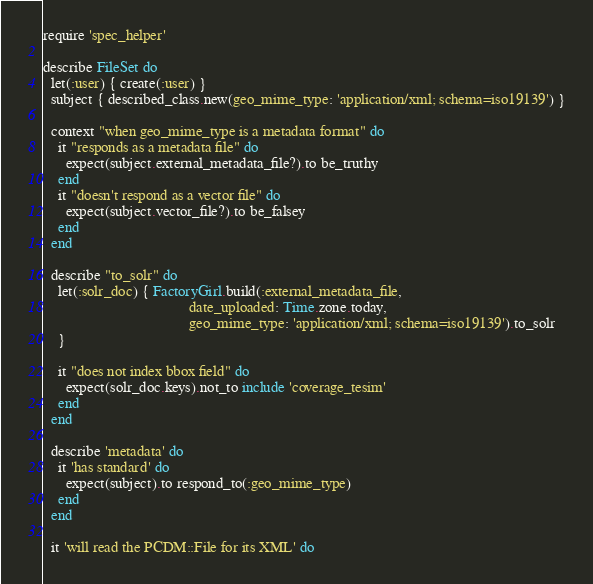<code> <loc_0><loc_0><loc_500><loc_500><_Ruby_>require 'spec_helper'

describe FileSet do
  let(:user) { create(:user) }
  subject { described_class.new(geo_mime_type: 'application/xml; schema=iso19139') }

  context "when geo_mime_type is a metadata format" do
    it "responds as a metadata file" do
      expect(subject.external_metadata_file?).to be_truthy
    end
    it "doesn't respond as a vector file" do
      expect(subject.vector_file?).to be_falsey
    end
  end

  describe "to_solr" do
    let(:solr_doc) { FactoryGirl.build(:external_metadata_file,
                                       date_uploaded: Time.zone.today,
                                       geo_mime_type: 'application/xml; schema=iso19139').to_solr
    }

    it "does not index bbox field" do
      expect(solr_doc.keys).not_to include 'coverage_tesim'
    end
  end

  describe 'metadata' do
    it 'has standard' do
      expect(subject).to respond_to(:geo_mime_type)
    end
  end

  it 'will read the PCDM::File for its XML' do</code> 